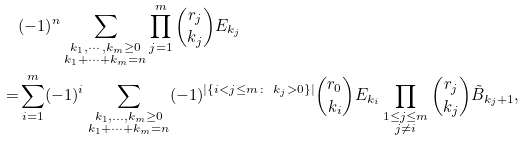<formula> <loc_0><loc_0><loc_500><loc_500>& ( - 1 ) ^ { n } \sum _ { \substack { k _ { 1 } , \cdots , k _ { m } \geq 0 \\ k _ { 1 } + \cdots + k _ { m } = n } } \prod _ { j = 1 } ^ { m } \binom { r _ { j } } { k _ { j } } E _ { k _ { j } } \\ = & \sum _ { i = 1 } ^ { m } ( - 1 ) ^ { i } \sum _ { \substack { k _ { 1 } , \dots , k _ { m } \geq 0 \\ k _ { 1 } + \cdots + k _ { m } = n } } ( - 1 ) ^ { | \{ i < j \leq m \colon \ k _ { j } > 0 \} | } \binom { r _ { 0 } } { k _ { i } } E _ { k _ { i } } \prod _ { \substack { 1 \leq j \leq m \\ j \not = i } } \binom { r _ { j } } { k _ { j } } \tilde { B } _ { k _ { j } + 1 } ,</formula> 